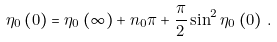Convert formula to latex. <formula><loc_0><loc_0><loc_500><loc_500>\eta _ { 0 } \left ( 0 \right ) = \eta _ { 0 } \left ( \infty \right ) + n _ { 0 } \pi + \frac { \pi } { 2 } \sin ^ { 2 } \eta _ { 0 } \left ( 0 \right ) \, .</formula> 